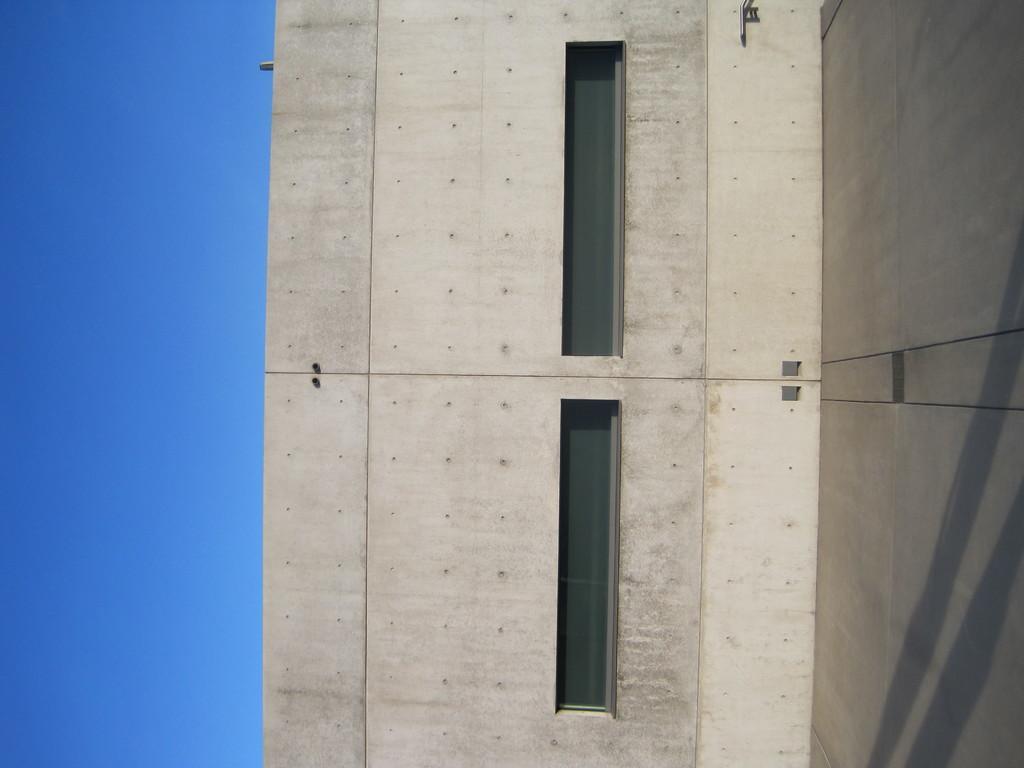Describe this image in one or two sentences. In this picture we can see a wall and windows. On the left side of the picture we can see sky. 